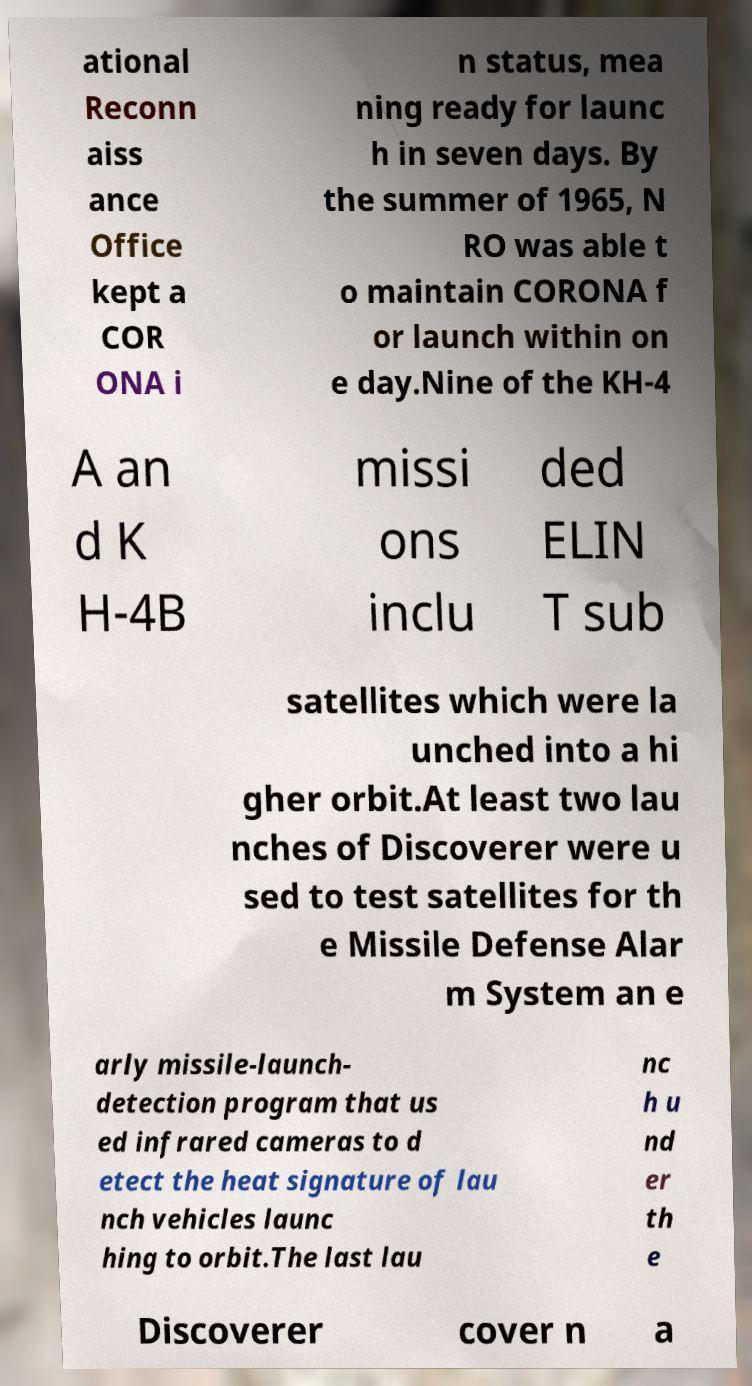What messages or text are displayed in this image? I need them in a readable, typed format. ational Reconn aiss ance Office kept a COR ONA i n status, mea ning ready for launc h in seven days. By the summer of 1965, N RO was able t o maintain CORONA f or launch within on e day.Nine of the KH-4 A an d K H-4B missi ons inclu ded ELIN T sub satellites which were la unched into a hi gher orbit.At least two lau nches of Discoverer were u sed to test satellites for th e Missile Defense Alar m System an e arly missile-launch- detection program that us ed infrared cameras to d etect the heat signature of lau nch vehicles launc hing to orbit.The last lau nc h u nd er th e Discoverer cover n a 